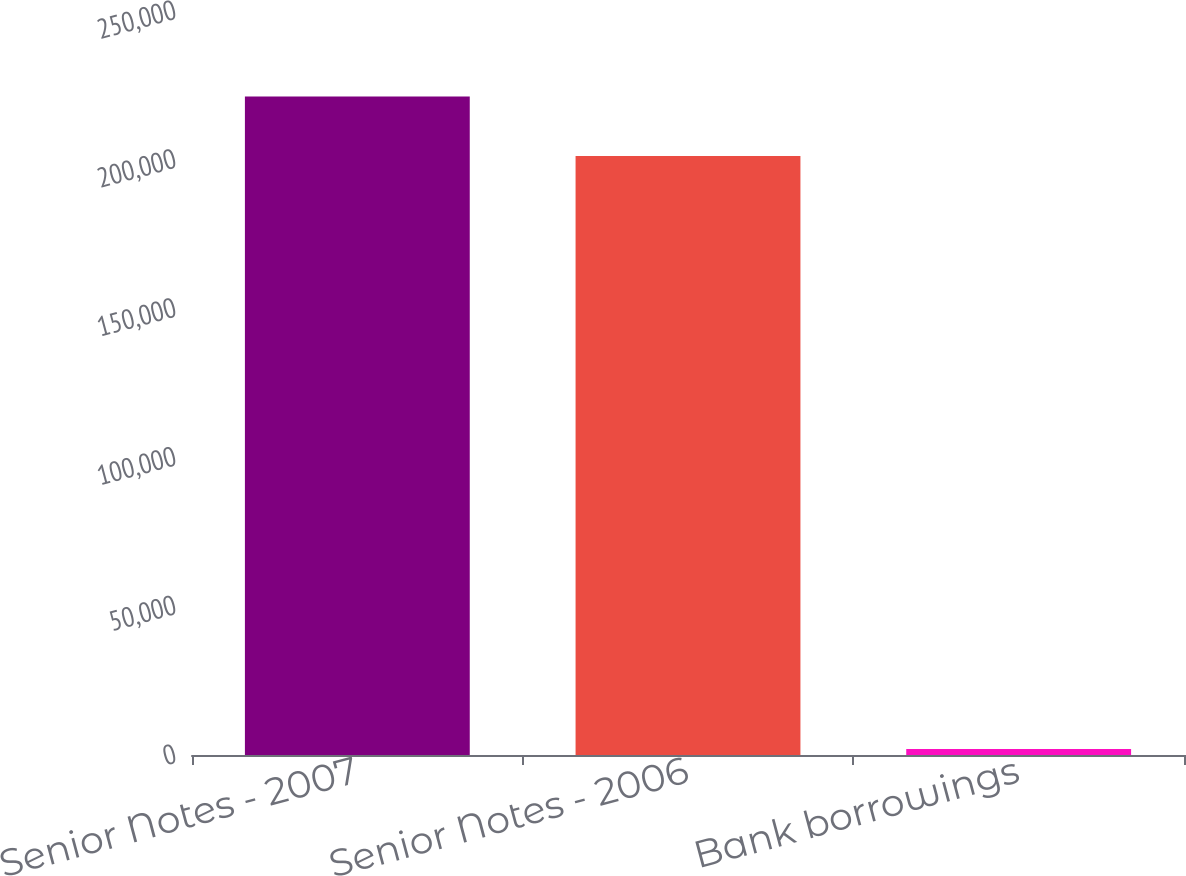Convert chart. <chart><loc_0><loc_0><loc_500><loc_500><bar_chart><fcel>Senior Notes - 2007<fcel>Senior Notes - 2006<fcel>Bank borrowings<nl><fcel>221288<fcel>201316<fcel>2012<nl></chart> 